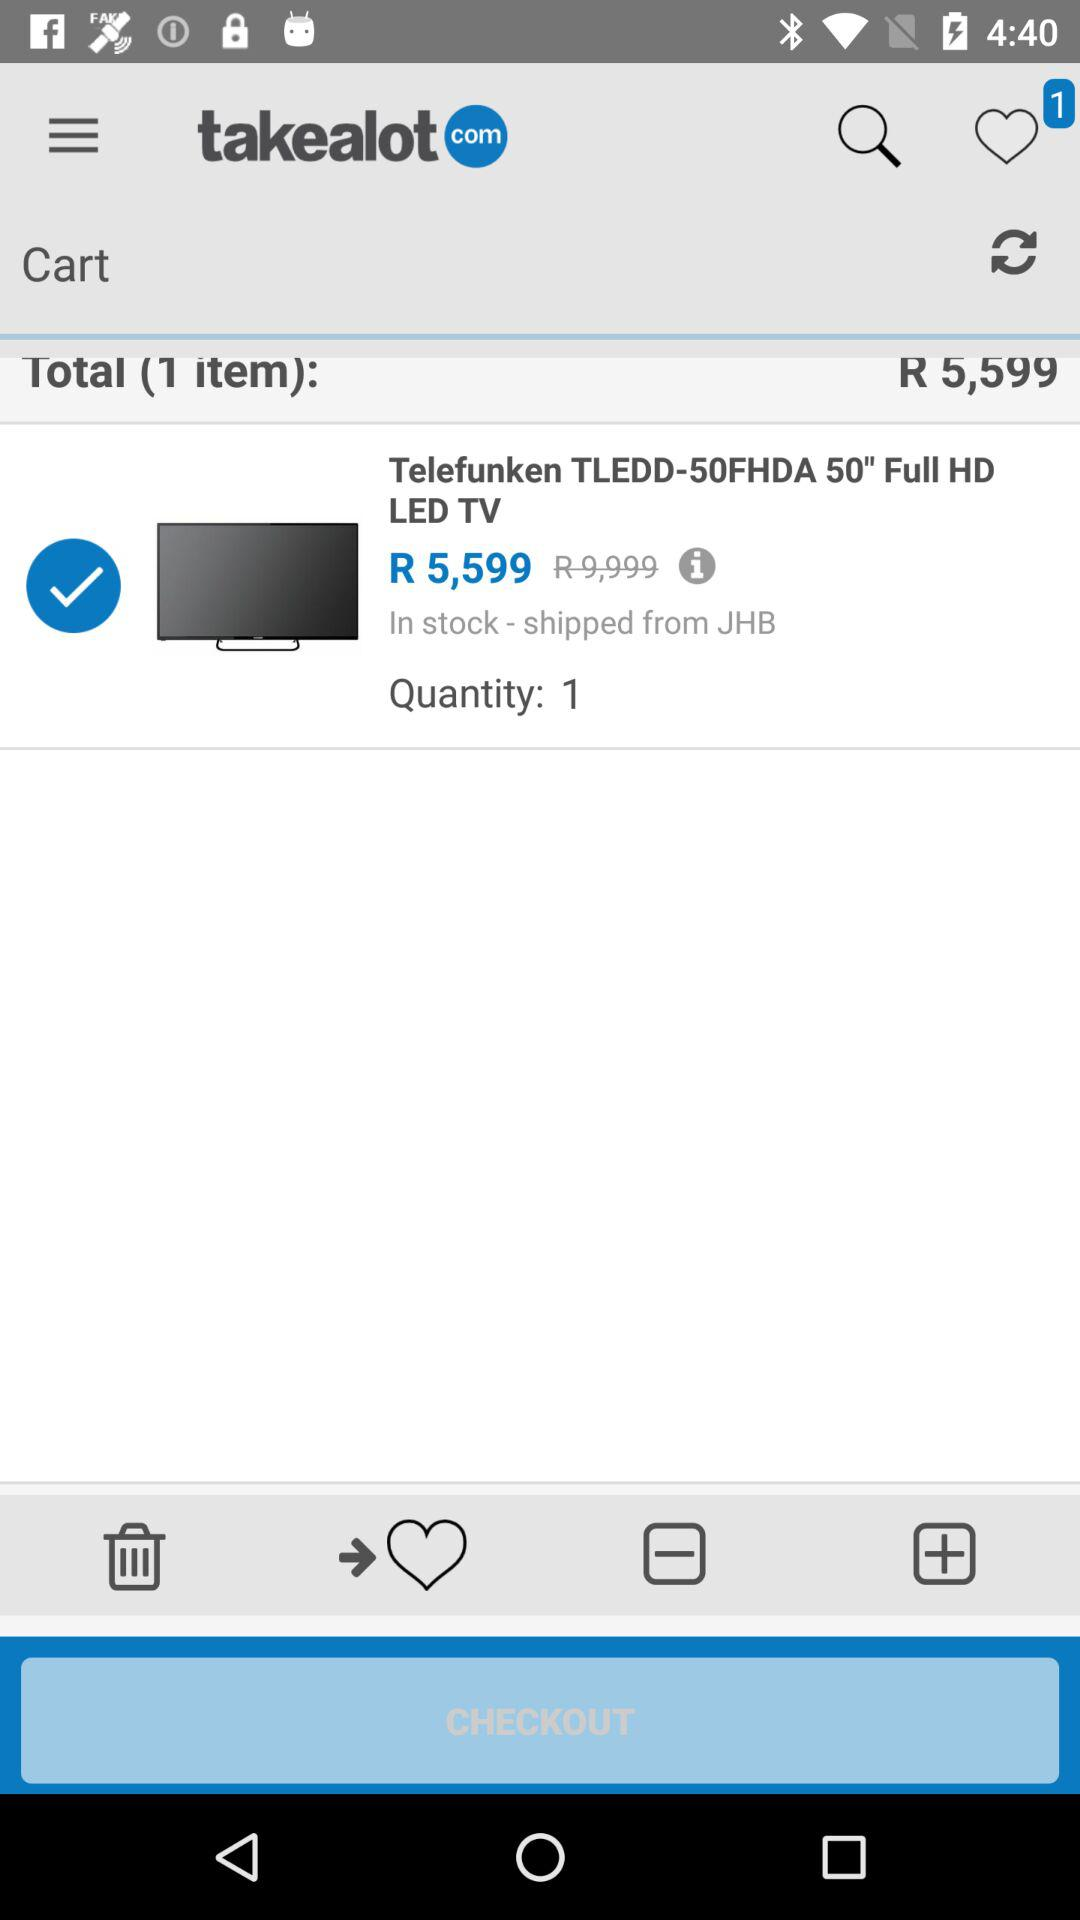Is "Telefunken TLEDD-50FHDA 50" Full HD LED TV" in stock? "Telefunken TLEDD-50FHDA 50" Full HD LED TV" is in stock. 